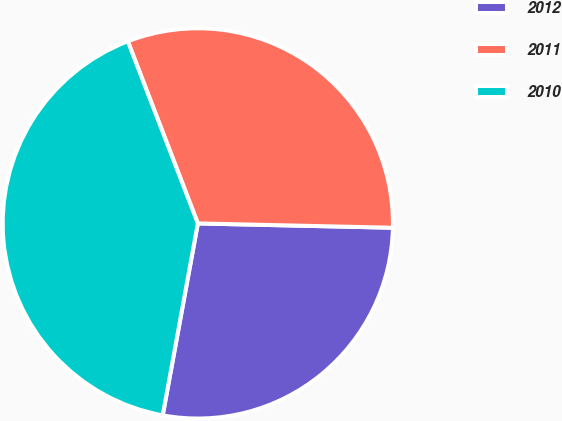Convert chart to OTSL. <chart><loc_0><loc_0><loc_500><loc_500><pie_chart><fcel>2012<fcel>2011<fcel>2010<nl><fcel>27.53%<fcel>31.2%<fcel>41.28%<nl></chart> 